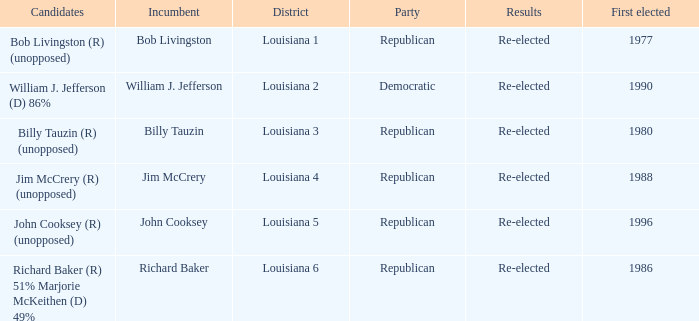What party does William J. Jefferson? Democratic. 